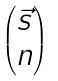<formula> <loc_0><loc_0><loc_500><loc_500>\begin{pmatrix} \vec { s } \\ n \end{pmatrix}</formula> 